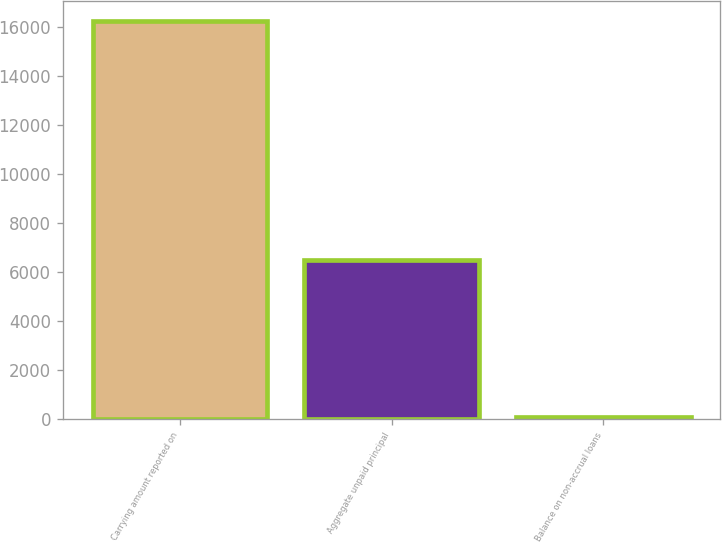Convert chart to OTSL. <chart><loc_0><loc_0><loc_500><loc_500><bar_chart><fcel>Carrying amount reported on<fcel>Aggregate unpaid principal<fcel>Balance on non-accrual loans<nl><fcel>16254<fcel>6501<fcel>77<nl></chart> 